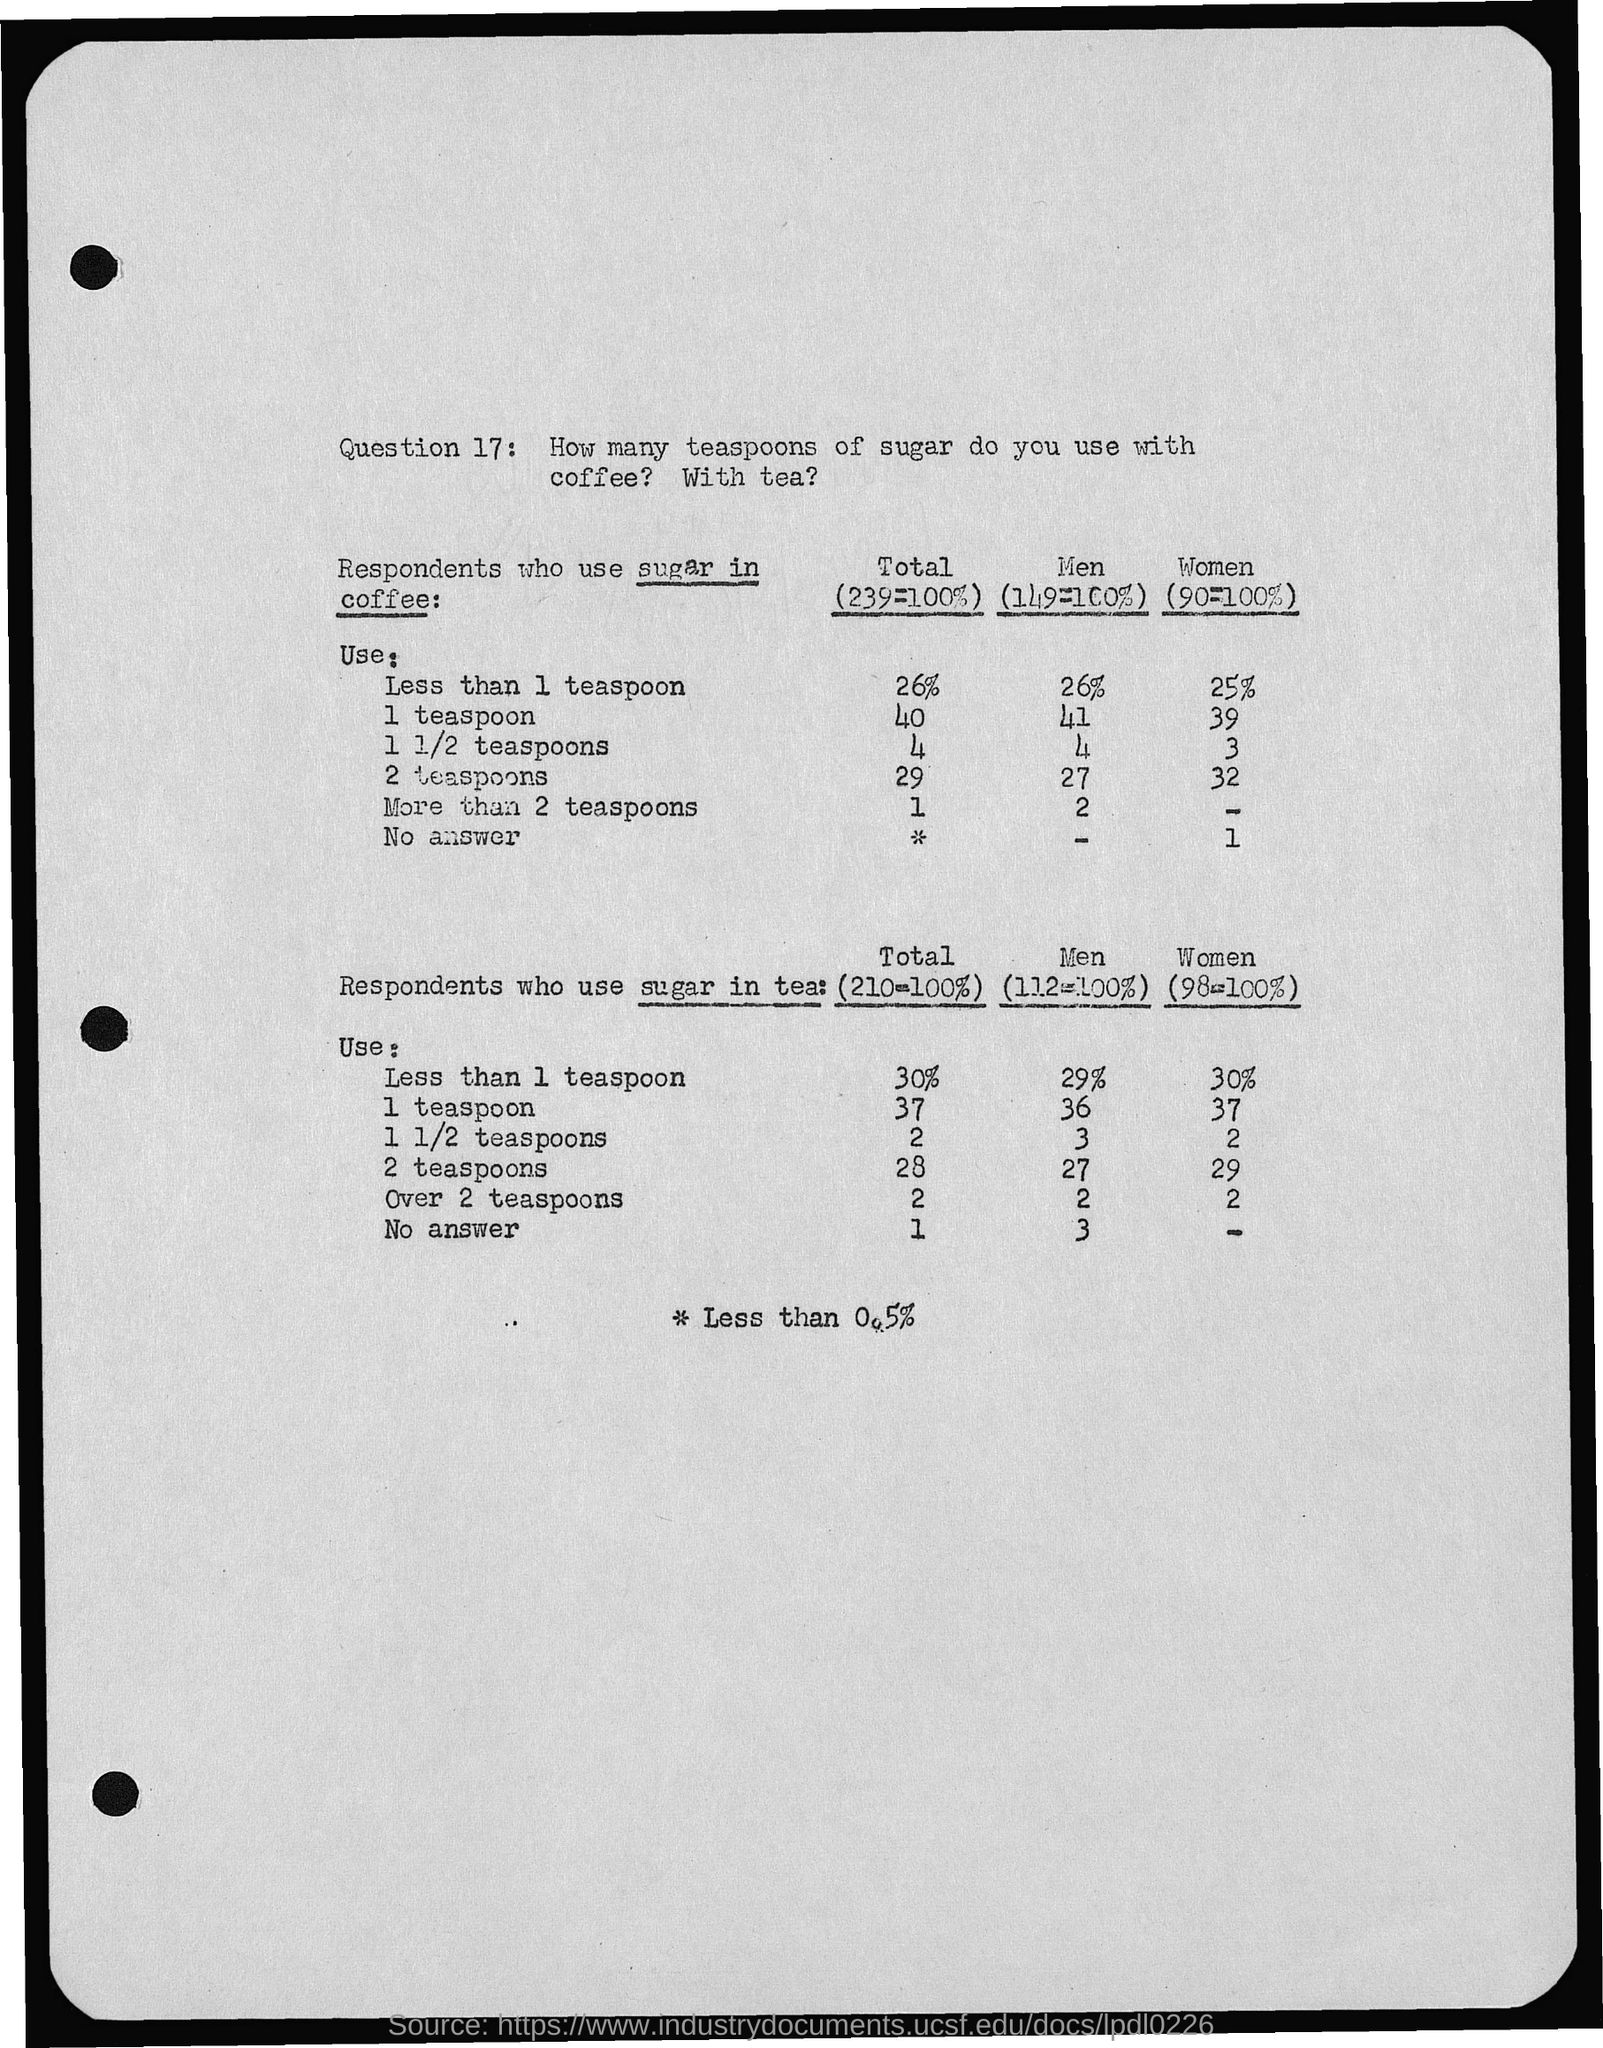What is Question 17?
Your response must be concise. How many teaspoons of sugar do you use with coffee? With tea?. What is the percentage of men who use less than 1 teaspoon sugar in coffee?
Your response must be concise. 26. What is the percentage of women who use less than 1 teaspoon sugar in coffee?
Ensure brevity in your answer.  25. What is the percentage of women who use less than 1 teaspoon sugar in tea?
Your response must be concise. 30. What is the percentage of men who use less than 1 teaspoon sugar in tea?
Keep it short and to the point. 29. 